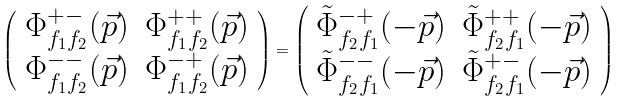<formula> <loc_0><loc_0><loc_500><loc_500>\left ( \begin{array} { * { 2 } { c } } \Phi _ { f _ { 1 } f _ { 2 } } ^ { + - } ( \vec { p } ) & \Phi _ { f _ { 1 } f _ { 2 } } ^ { + + } ( \vec { p } ) \\ \Phi _ { f _ { 1 } f _ { 2 } } ^ { - - } ( \vec { p } ) & \Phi _ { f _ { 1 } f _ { 2 } } ^ { - + } ( \vec { p } ) \end{array} \right ) = \left ( \begin{array} { * { 2 } { c } } \tilde { \Phi } _ { f _ { 2 } f _ { 1 } } ^ { - + } ( - \vec { p } ) & \tilde { \Phi } _ { f _ { 2 } f _ { 1 } } ^ { + + } ( - \vec { p } ) \\ \tilde { \Phi } _ { f _ { 2 } f _ { 1 } } ^ { - - } ( - \vec { p } ) & \tilde { \Phi } _ { f _ { 2 } f _ { 1 } } ^ { + - } ( - \vec { p } ) \end{array} \right )</formula> 